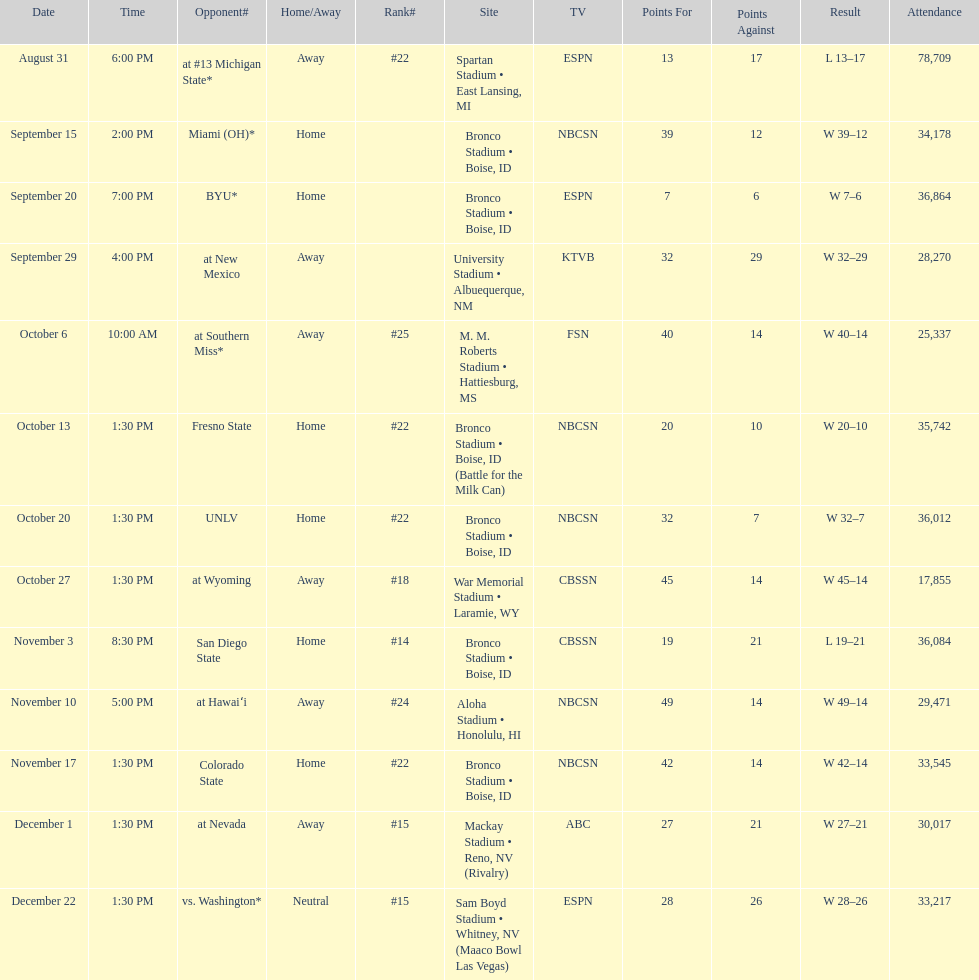What is the total number of games played at bronco stadium? 6. 